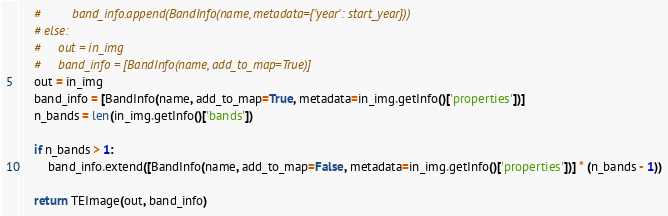Convert code to text. <code><loc_0><loc_0><loc_500><loc_500><_Python_>    #         band_info.append(BandInfo(name, metadata={'year': start_year}))
    # else:
    #     out = in_img
    #     band_info = [BandInfo(name, add_to_map=True)]
    out = in_img
    band_info = [BandInfo(name, add_to_map=True, metadata=in_img.getInfo()['properties'])]
    n_bands = len(in_img.getInfo()['bands'])
    
    if n_bands > 1:
        band_info.extend([BandInfo(name, add_to_map=False, metadata=in_img.getInfo()['properties'])] * (n_bands - 1))

    return TEImage(out, band_info)
</code> 